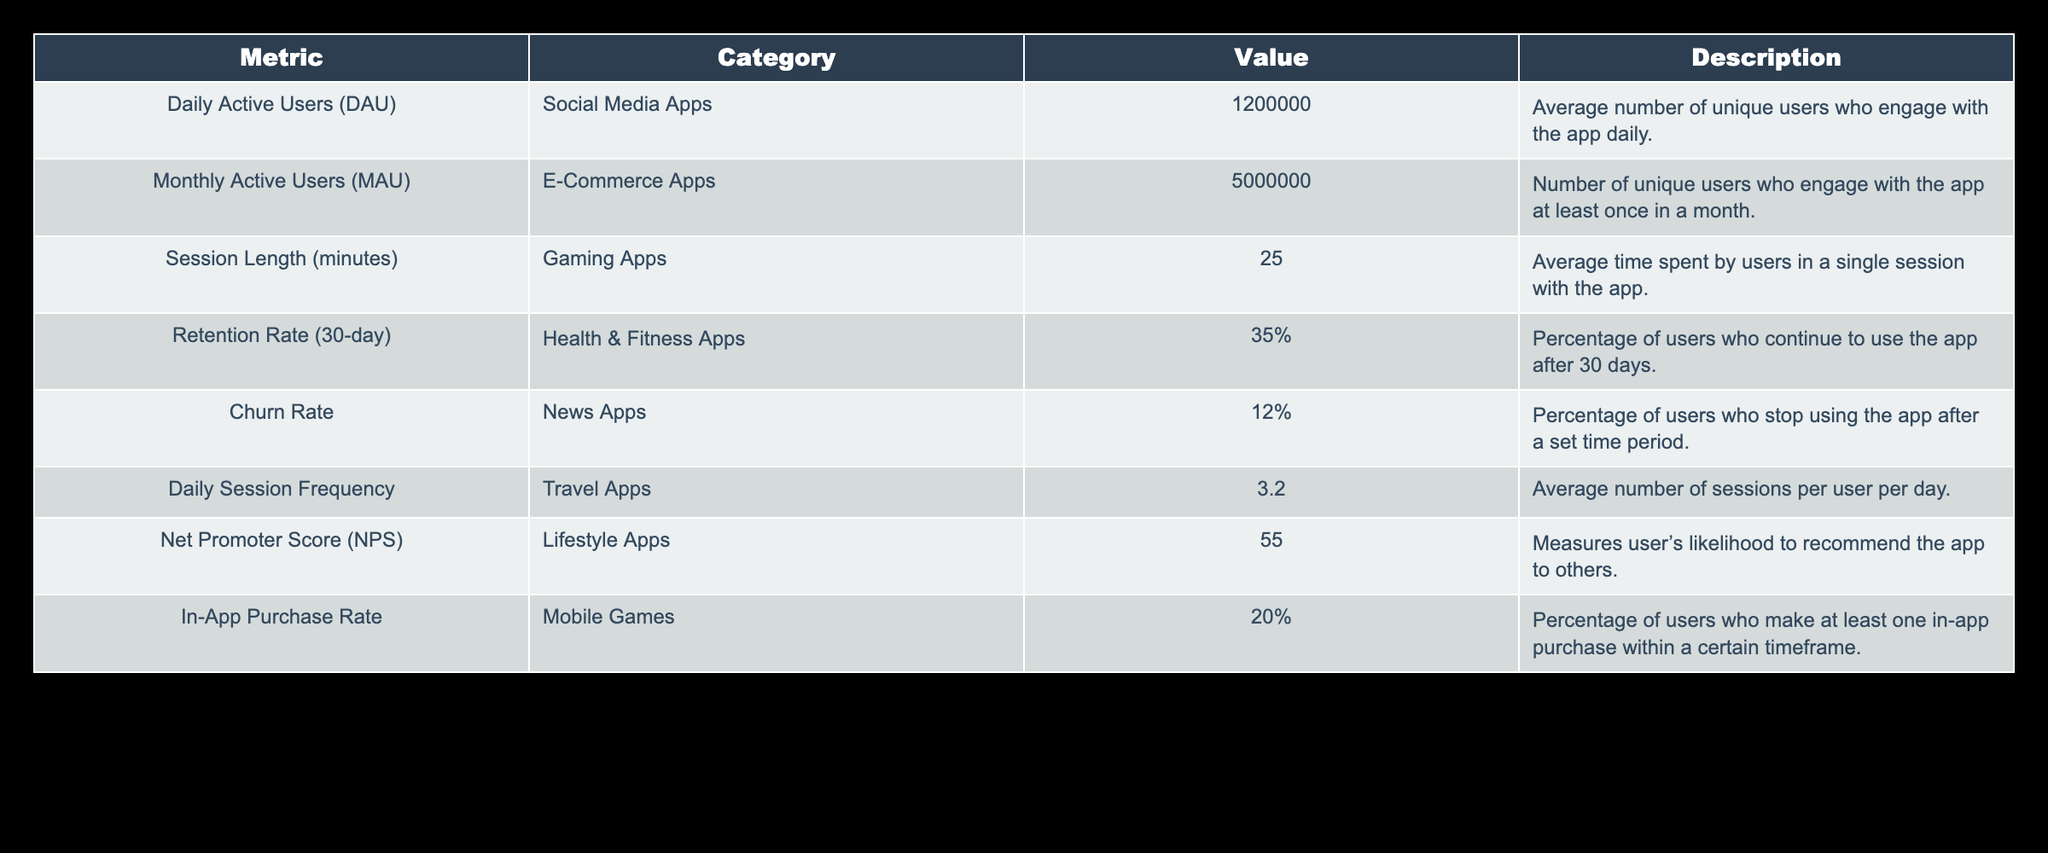What is the Daily Active Users (DAU) for Social Media Apps? The table directly lists the Daily Active Users (DAU) for Social Media Apps as 1,200,000.
Answer: 1,200,000 What is the percentage of users who make in-app purchases in Mobile Games? The table shows that the In-App Purchase Rate for Mobile Games is 20%.
Answer: 20% What is the average session length for Gaming Apps? According to the table, the average session length for Gaming Apps is 25 minutes.
Answer: 25 minutes Which app category has the highest Monthly Active Users (MAU)? The category with the highest Monthly Active Users is E-Commerce Apps with 5,000,000 users.
Answer: E-Commerce Apps What is the average number of sessions per user per day for Travel Apps? The value for Daily Session Frequency for Travel Apps is 3.2, indicating the average number of sessions per user per day.
Answer: 3.2 Is the Retention Rate for Health & Fitness Apps higher than the Churn Rate for News Apps? The Retention Rate for Health & Fitness Apps is 35%, while the Churn Rate for News Apps is 12%, thus the Retention Rate is higher.
Answer: Yes How many unique users engage with the app daily according to the table? The Daily Active Users (DAU) metric shows 1,200,000 unique users engage with Social Media apps daily.
Answer: 1,200,000 What is the difference between the Retention Rate and Churn Rate percentage values? The Retention Rate is 35% and the Churn Rate is 12%. The difference is 35% - 12% = 23%.
Answer: 23% Do Lifestyle Apps have a Net Promoter Score (NPS) above 50? The Net Promoter Score (NPS) for Lifestyle Apps according to the table is 55, which is indeed above 50.
Answer: Yes What is the average user engagement (in sessions) if there is a combined engagement from 3.2 average sessions per day with 1,200,000 users? To find the average user engagement, multiply the average sessions per day (3.2) by the number of users (1,200,000), resulting in 3.2 * 1,200,000 = 3,840,000 sessions per day.
Answer: 3,840,000 sessions per day 